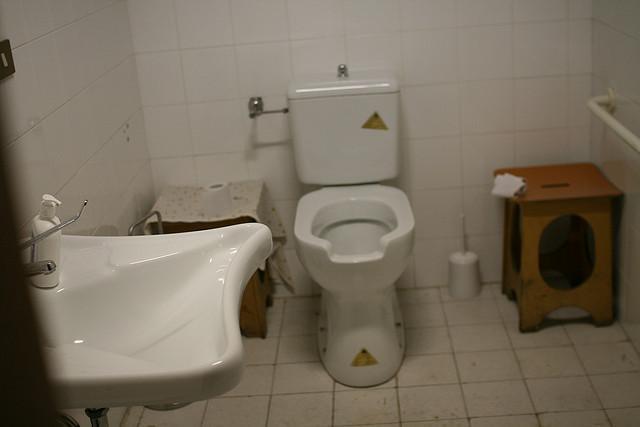How many sinks?
Give a very brief answer. 1. How many sinks are being used?
Give a very brief answer. 0. How many toilets are there?
Give a very brief answer. 1. How many sinks are in this room?
Give a very brief answer. 1. 